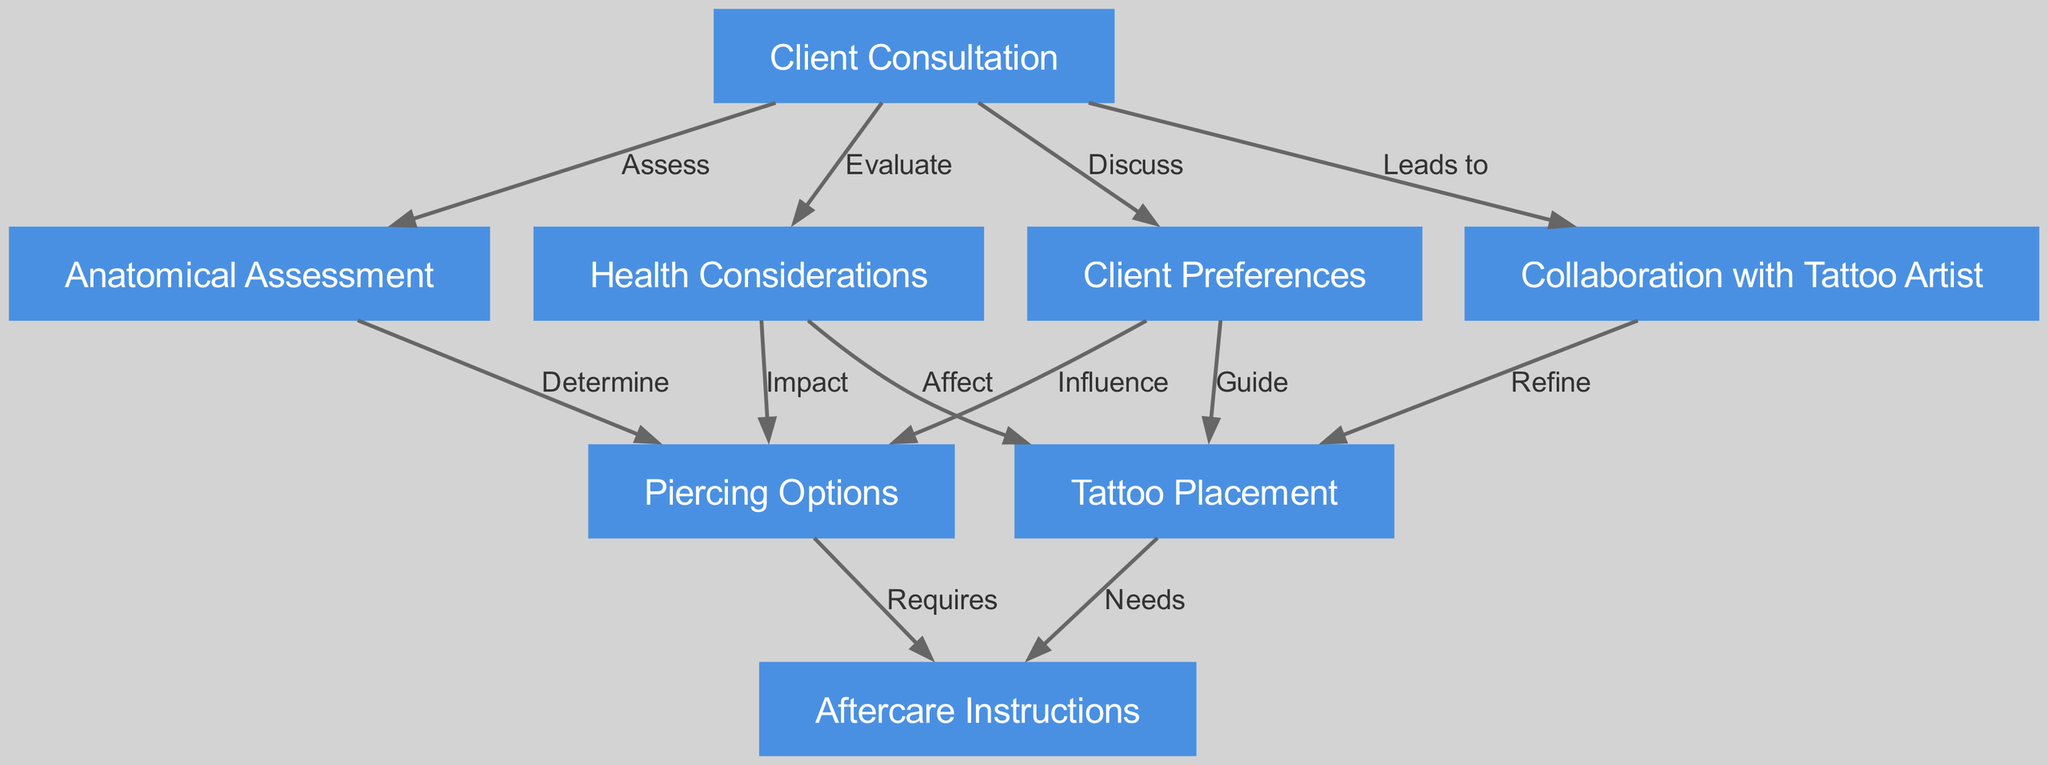What is the main purpose of the diagram? The diagram illustrates the client consultation process for determining suitable piercings and tattoo placements. It includes nodes for various aspects of the consultation and their interconnections, showing how these elements interact to support the decision-making process for clients seeking modifications.
Answer: Client Consultation How many nodes are in the diagram? By counting each individual node listed within the nodes section of the diagram, we find there are eight distinct points of focus regarding the consultation process.
Answer: 8 What does the "Collaboration with Tattoo Artist" node lead to? Following the directional edge labeled 'Leads to' from the "Client Consultation" to "Collaboration with Tattoo Artist" and then from "Collaboration with Tattoo Artist" to "Tattoo Placement," we conclude that this collaboration refines tattoo placement decisions based on the assessment process.
Answer: Tattoo Placement Which node represents the assessment of the client's body? The "Anatomical Assessment" node specifically indicates the action of assessing the physical aspects of the client's body, which is crucial for identifying suitable piercings.
Answer: Anatomical Assessment What factors influence the options for piercings? The edges labeled 'Discuss' from "Client Preferences" and 'Determine' from "Anatomical Assessment" show that both the client's individual preferences and the anatomical capabilities significantly impact the available piercing options.
Answer: Client Preferences and Anatomical Assessment How does health impact the choice of tattoo? There is a directed edge labeled 'Affect' from the "Health Considerations" node leading to the "Tattoo Placement," indicating that health issues can influence decisions about tattoo placements, along with potential implications on healing.
Answer: Health Considerations What are the aftercare requirements for piercings? The edge labeled 'Requires' from the "Piercing Options" node leads to the "Aftercare Instructions" node, signifying that certain aftercare will be necessary following a piercing.
Answer: Aftercare Instructions Which node is discussed in relation to client preferences? The "Tattoo Placement" node is linked to the "Client Preferences" node through the edge labeled 'Guide.' This reflects the need to consider client preferences when determining tattoo placements.
Answer: Tattoo Placement What is the primary action taken during the client consultation? The predominant action is to 'Discuss' which involves the client expressing their preferences, ultimately steering the entire consultation process towards finding suitable body modifications.
Answer: Discuss 